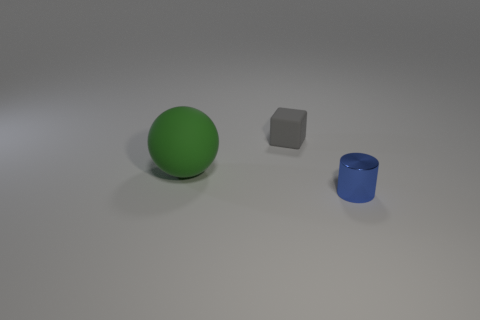What is the lighting like in this scene? The lighting in the scene is soft and diffused, casting gentle shadows to the right of the objects, suggesting a light source coming from the left. 